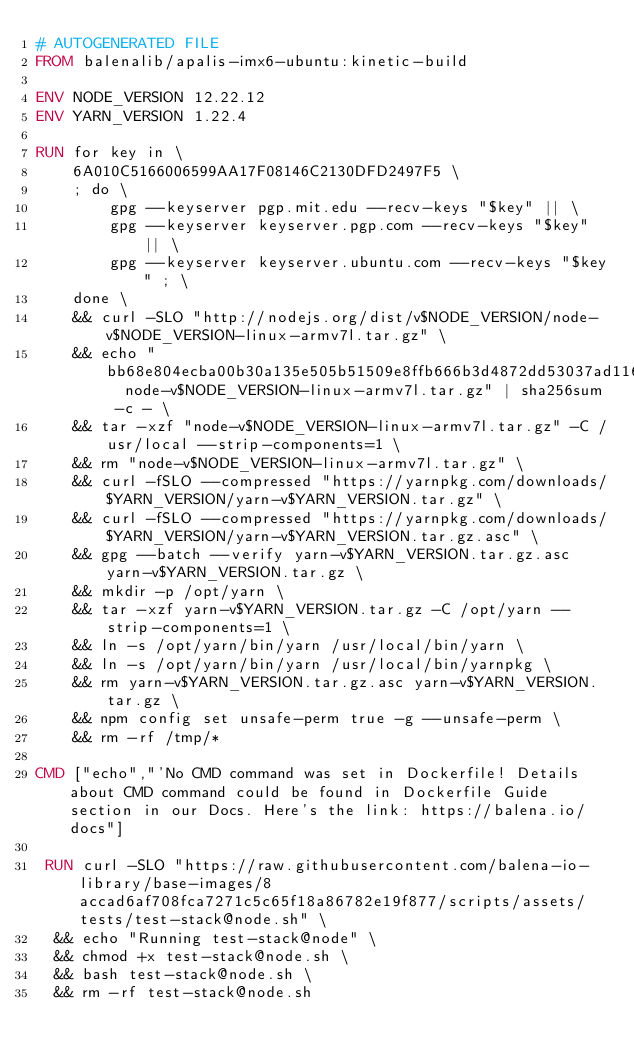<code> <loc_0><loc_0><loc_500><loc_500><_Dockerfile_># AUTOGENERATED FILE
FROM balenalib/apalis-imx6-ubuntu:kinetic-build

ENV NODE_VERSION 12.22.12
ENV YARN_VERSION 1.22.4

RUN for key in \
	6A010C5166006599AA17F08146C2130DFD2497F5 \
	; do \
		gpg --keyserver pgp.mit.edu --recv-keys "$key" || \
		gpg --keyserver keyserver.pgp.com --recv-keys "$key" || \
		gpg --keyserver keyserver.ubuntu.com --recv-keys "$key" ; \
	done \
	&& curl -SLO "http://nodejs.org/dist/v$NODE_VERSION/node-v$NODE_VERSION-linux-armv7l.tar.gz" \
	&& echo "bb68e804ecba00b30a135e505b51509e8ffb666b3d4872dd53037ad11699174c  node-v$NODE_VERSION-linux-armv7l.tar.gz" | sha256sum -c - \
	&& tar -xzf "node-v$NODE_VERSION-linux-armv7l.tar.gz" -C /usr/local --strip-components=1 \
	&& rm "node-v$NODE_VERSION-linux-armv7l.tar.gz" \
	&& curl -fSLO --compressed "https://yarnpkg.com/downloads/$YARN_VERSION/yarn-v$YARN_VERSION.tar.gz" \
	&& curl -fSLO --compressed "https://yarnpkg.com/downloads/$YARN_VERSION/yarn-v$YARN_VERSION.tar.gz.asc" \
	&& gpg --batch --verify yarn-v$YARN_VERSION.tar.gz.asc yarn-v$YARN_VERSION.tar.gz \
	&& mkdir -p /opt/yarn \
	&& tar -xzf yarn-v$YARN_VERSION.tar.gz -C /opt/yarn --strip-components=1 \
	&& ln -s /opt/yarn/bin/yarn /usr/local/bin/yarn \
	&& ln -s /opt/yarn/bin/yarn /usr/local/bin/yarnpkg \
	&& rm yarn-v$YARN_VERSION.tar.gz.asc yarn-v$YARN_VERSION.tar.gz \
	&& npm config set unsafe-perm true -g --unsafe-perm \
	&& rm -rf /tmp/*

CMD ["echo","'No CMD command was set in Dockerfile! Details about CMD command could be found in Dockerfile Guide section in our Docs. Here's the link: https://balena.io/docs"]

 RUN curl -SLO "https://raw.githubusercontent.com/balena-io-library/base-images/8accad6af708fca7271c5c65f18a86782e19f877/scripts/assets/tests/test-stack@node.sh" \
  && echo "Running test-stack@node" \
  && chmod +x test-stack@node.sh \
  && bash test-stack@node.sh \
  && rm -rf test-stack@node.sh 
</code> 